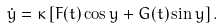<formula> <loc_0><loc_0><loc_500><loc_500>\dot { y } = \kappa \left [ F ( t ) \cos y + G ( t ) \sin y \right ] .</formula> 